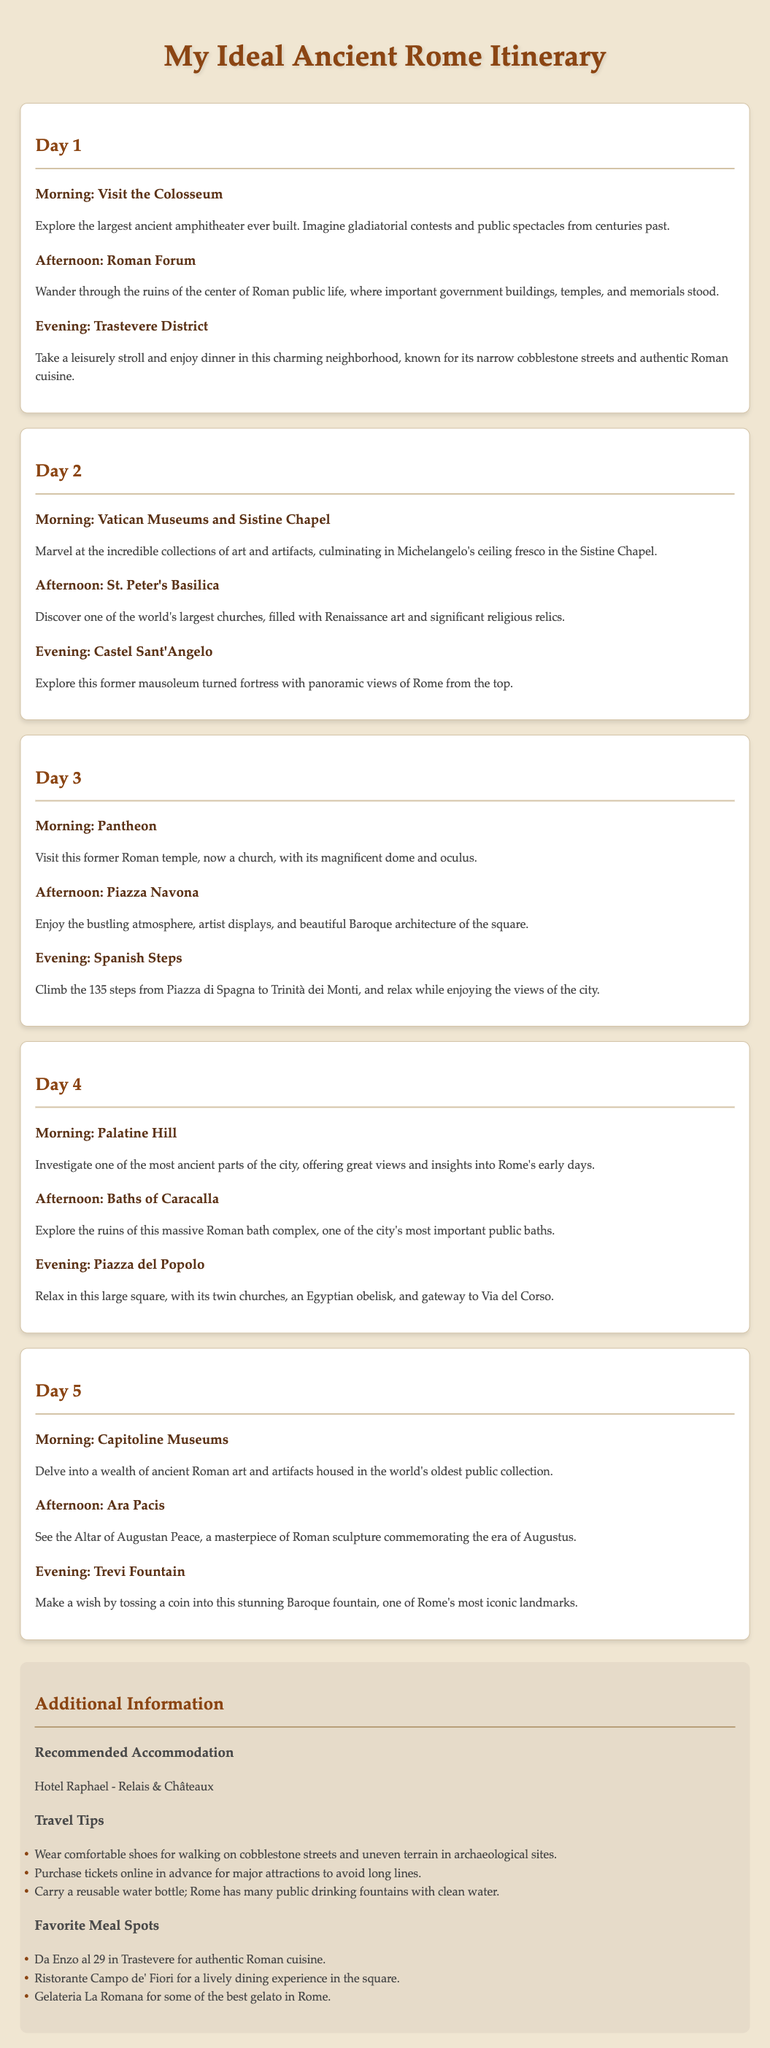What is the title of the itinerary? The title of the itinerary is found at the top of the document, which includes the name of the ideal travel plan.
Answer: My Ideal Ancient Rome Itinerary What is the first activity on Day 1? The first activity listed in Day 1 provides the morning plan for visitors.
Answer: Visit the Colosseum How many days are included in the itinerary? The document outlines the total number of days planned for the itinerary, which can be counted directly.
Answer: 5 What is a recommended accommodation mentioned in the document? The itinerary provides a specific hotel recommendation for travelers seeking a place to stay.
Answer: Hotel Raphael - Relais & Châteaux What is the last activity on Day 5? The last activity mentioned on Day 5 indicates a significant landmark to visit at the end of the itinerary.
Answer: Trevi Fountain What is the purpose of visiting the Vatican Museums? This question requires understanding of the significance of the site listed in the itinerary.
Answer: To marvel at art and artifacts How many steps are there to climb at the Spanish Steps? The document specifies the exact number of steps that visitors need to climb, making it a straightforward detail.
Answer: 135 What kind of cuisine is recommended in Trastevere? This question aims to gather specific information about local dining experiences in the highlighted area.
Answer: Authentic Roman cuisine Which monument is the centerpiece of the suggested visit on Day 4? This inquiry connects to Day 4's itinerary and identifies one key location to explore.
Answer: Palatine Hill 